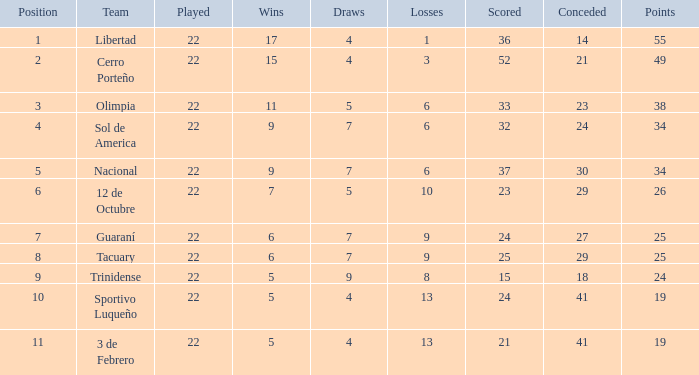When the scored value was 25, how many losses were there? 9.0. 